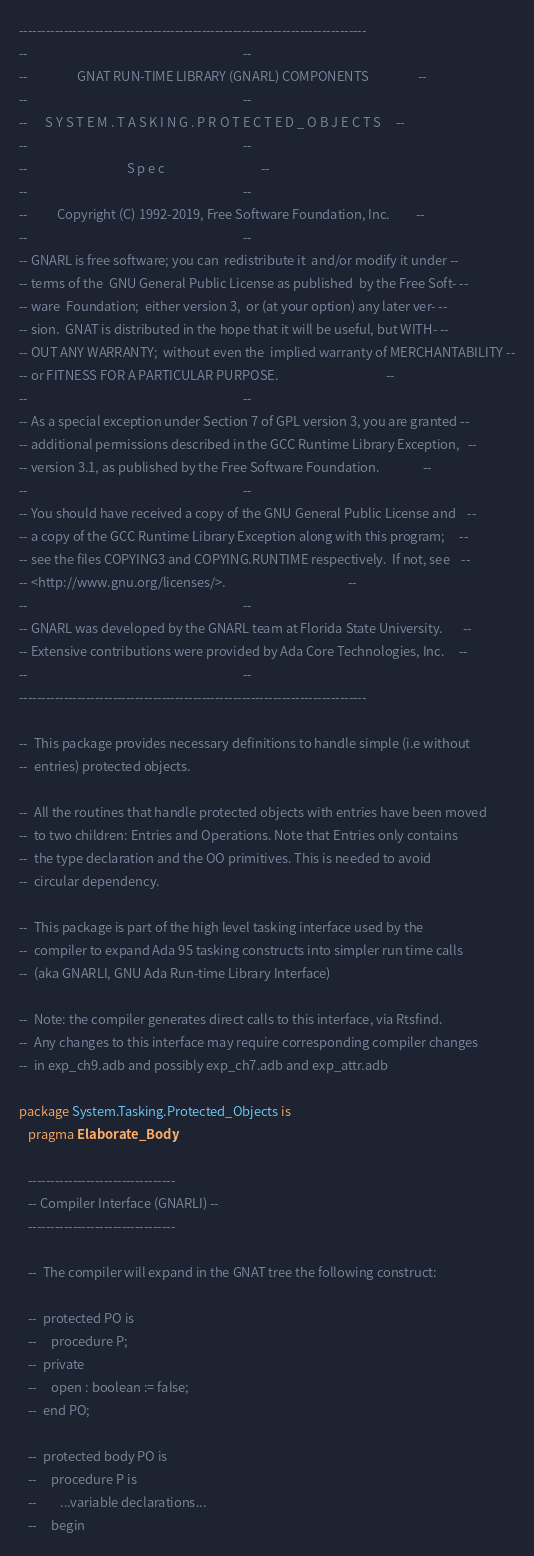<code> <loc_0><loc_0><loc_500><loc_500><_Ada_>------------------------------------------------------------------------------
--                                                                          --
--                 GNAT RUN-TIME LIBRARY (GNARL) COMPONENTS                 --
--                                                                          --
--      S Y S T E M . T A S K I N G . P R O T E C T E D _ O B J E C T S     --
--                                                                          --
--                                  S p e c                                 --
--                                                                          --
--          Copyright (C) 1992-2019, Free Software Foundation, Inc.         --
--                                                                          --
-- GNARL is free software; you can  redistribute it  and/or modify it under --
-- terms of the  GNU General Public License as published  by the Free Soft- --
-- ware  Foundation;  either version 3,  or (at your option) any later ver- --
-- sion.  GNAT is distributed in the hope that it will be useful, but WITH- --
-- OUT ANY WARRANTY;  without even the  implied warranty of MERCHANTABILITY --
-- or FITNESS FOR A PARTICULAR PURPOSE.                                     --
--                                                                          --
-- As a special exception under Section 7 of GPL version 3, you are granted --
-- additional permissions described in the GCC Runtime Library Exception,   --
-- version 3.1, as published by the Free Software Foundation.               --
--                                                                          --
-- You should have received a copy of the GNU General Public License and    --
-- a copy of the GCC Runtime Library Exception along with this program;     --
-- see the files COPYING3 and COPYING.RUNTIME respectively.  If not, see    --
-- <http://www.gnu.org/licenses/>.                                          --
--                                                                          --
-- GNARL was developed by the GNARL team at Florida State University.       --
-- Extensive contributions were provided by Ada Core Technologies, Inc.     --
--                                                                          --
------------------------------------------------------------------------------

--  This package provides necessary definitions to handle simple (i.e without
--  entries) protected objects.

--  All the routines that handle protected objects with entries have been moved
--  to two children: Entries and Operations. Note that Entries only contains
--  the type declaration and the OO primitives. This is needed to avoid
--  circular dependency.

--  This package is part of the high level tasking interface used by the
--  compiler to expand Ada 95 tasking constructs into simpler run time calls
--  (aka GNARLI, GNU Ada Run-time Library Interface)

--  Note: the compiler generates direct calls to this interface, via Rtsfind.
--  Any changes to this interface may require corresponding compiler changes
--  in exp_ch9.adb and possibly exp_ch7.adb and exp_attr.adb

package System.Tasking.Protected_Objects is
   pragma Elaborate_Body;

   ---------------------------------
   -- Compiler Interface (GNARLI) --
   ---------------------------------

   --  The compiler will expand in the GNAT tree the following construct:

   --  protected PO is
   --     procedure P;
   --  private
   --     open : boolean := false;
   --  end PO;

   --  protected body PO is
   --     procedure P is
   --        ...variable declarations...
   --     begin</code> 